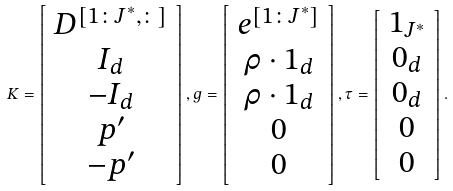Convert formula to latex. <formula><loc_0><loc_0><loc_500><loc_500>K = \left [ \begin{array} { c } D ^ { [ 1 \colon J ^ { * } , \colon ] } \\ I _ { d } \\ - I _ { d } \\ p ^ { \prime } \\ - p ^ { \prime } \end{array} \right ] , g = \left [ \begin{array} { c } e ^ { [ 1 \colon J ^ { * } ] } \\ \rho \cdot 1 _ { d } \\ \rho \cdot 1 _ { d } \\ 0 \\ 0 \end{array} \right ] , \tau = \left [ \begin{array} { c } 1 _ { J ^ { * } } \\ 0 _ { d } \\ 0 _ { d } \\ 0 \\ 0 \end{array} \right ] .</formula> 